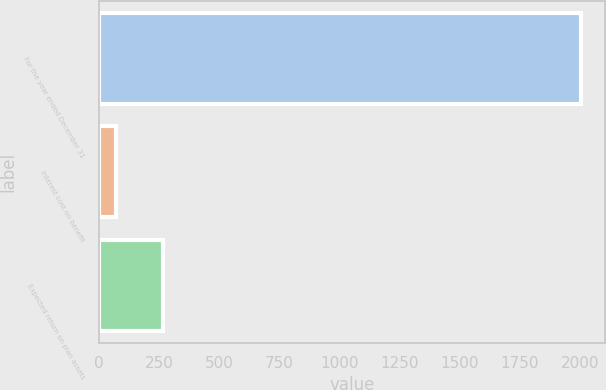<chart> <loc_0><loc_0><loc_500><loc_500><bar_chart><fcel>For the year ended December 31<fcel>Interest cost on benefit<fcel>Expected return on plan assets<nl><fcel>2003<fcel>73<fcel>266<nl></chart> 